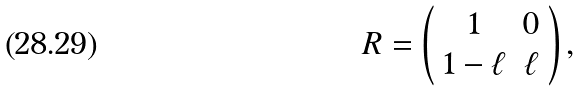<formula> <loc_0><loc_0><loc_500><loc_500>R = \left ( \begin{array} { c c } 1 & 0 \\ 1 - \ell & \ell \\ \end{array} \right ) ,</formula> 